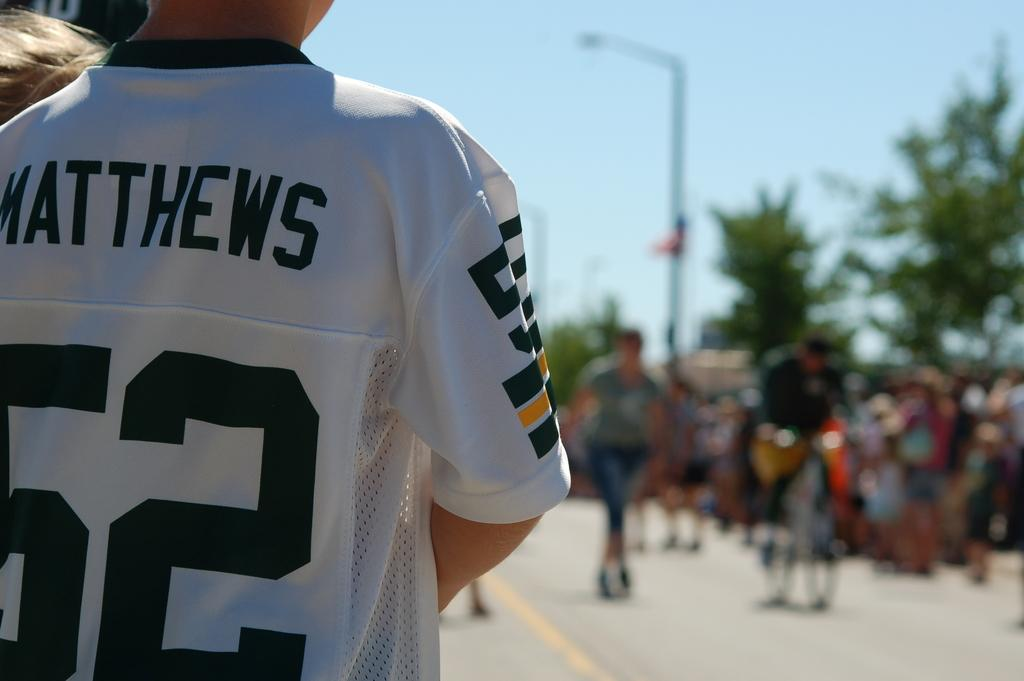<image>
Create a compact narrative representing the image presented. A boy in a white jersey that says Matthews 62 appears to be watching a parade. 